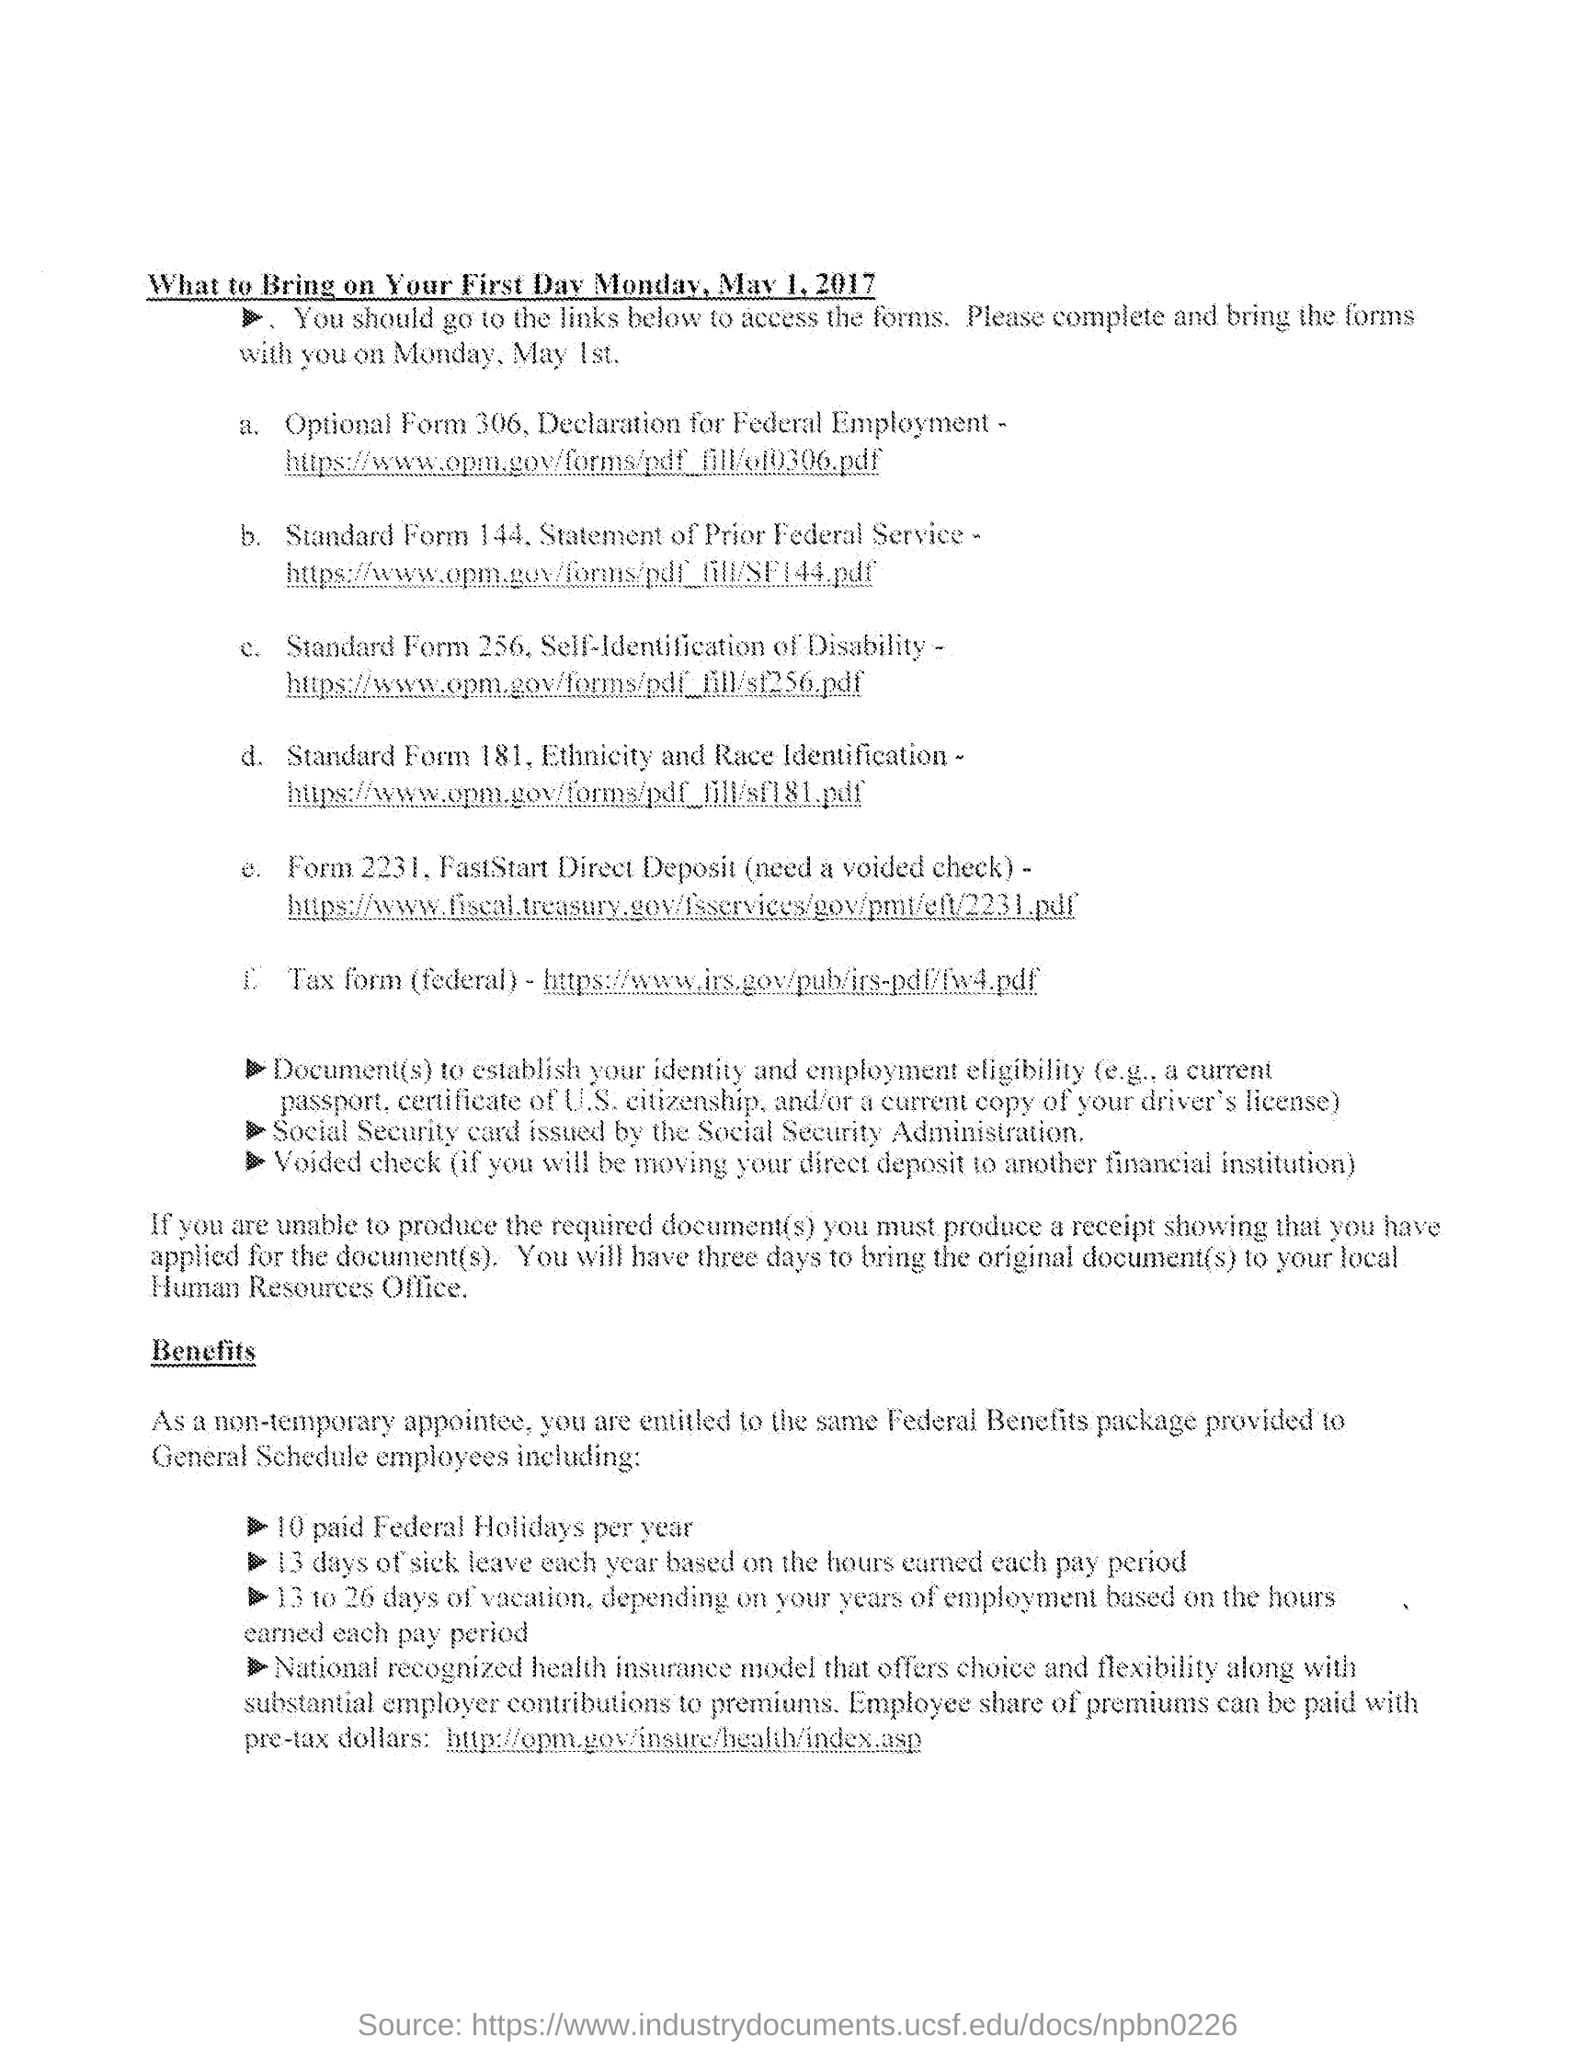What is the first day mentioned?
Provide a short and direct response. MONDAY, MAY 1, 2017. In what case do they have to bring a Voided check?
Keep it short and to the point. If you will be moving your direct deposit to another financial institution. 